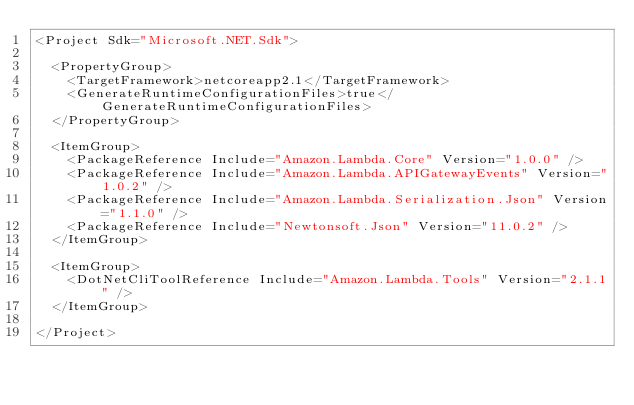Convert code to text. <code><loc_0><loc_0><loc_500><loc_500><_XML_><Project Sdk="Microsoft.NET.Sdk">

  <PropertyGroup>
    <TargetFramework>netcoreapp2.1</TargetFramework>
    <GenerateRuntimeConfigurationFiles>true</GenerateRuntimeConfigurationFiles>
  </PropertyGroup>

  <ItemGroup>
    <PackageReference Include="Amazon.Lambda.Core" Version="1.0.0" />
    <PackageReference Include="Amazon.Lambda.APIGatewayEvents" Version="1.0.2" />
    <PackageReference Include="Amazon.Lambda.Serialization.Json" Version="1.1.0" />
    <PackageReference Include="Newtonsoft.Json" Version="11.0.2" />
  </ItemGroup>

  <ItemGroup>
    <DotNetCliToolReference Include="Amazon.Lambda.Tools" Version="2.1.1" />
  </ItemGroup>

</Project>
</code> 